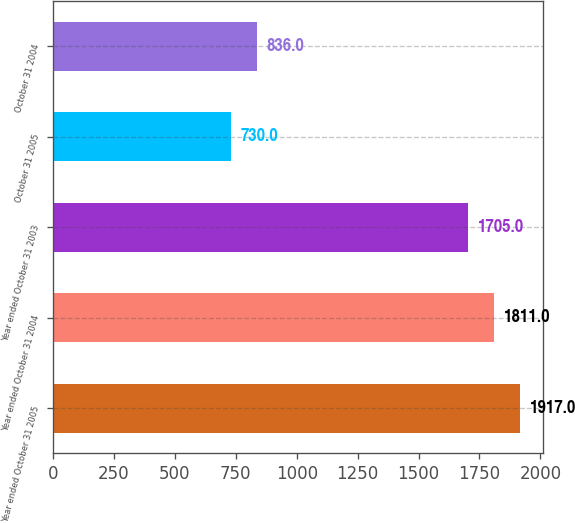Convert chart. <chart><loc_0><loc_0><loc_500><loc_500><bar_chart><fcel>Year ended October 31 2005<fcel>Year ended October 31 2004<fcel>Year ended October 31 2003<fcel>October 31 2005<fcel>October 31 2004<nl><fcel>1917<fcel>1811<fcel>1705<fcel>730<fcel>836<nl></chart> 